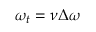<formula> <loc_0><loc_0><loc_500><loc_500>\omega _ { t } = \nu \Delta \omega</formula> 